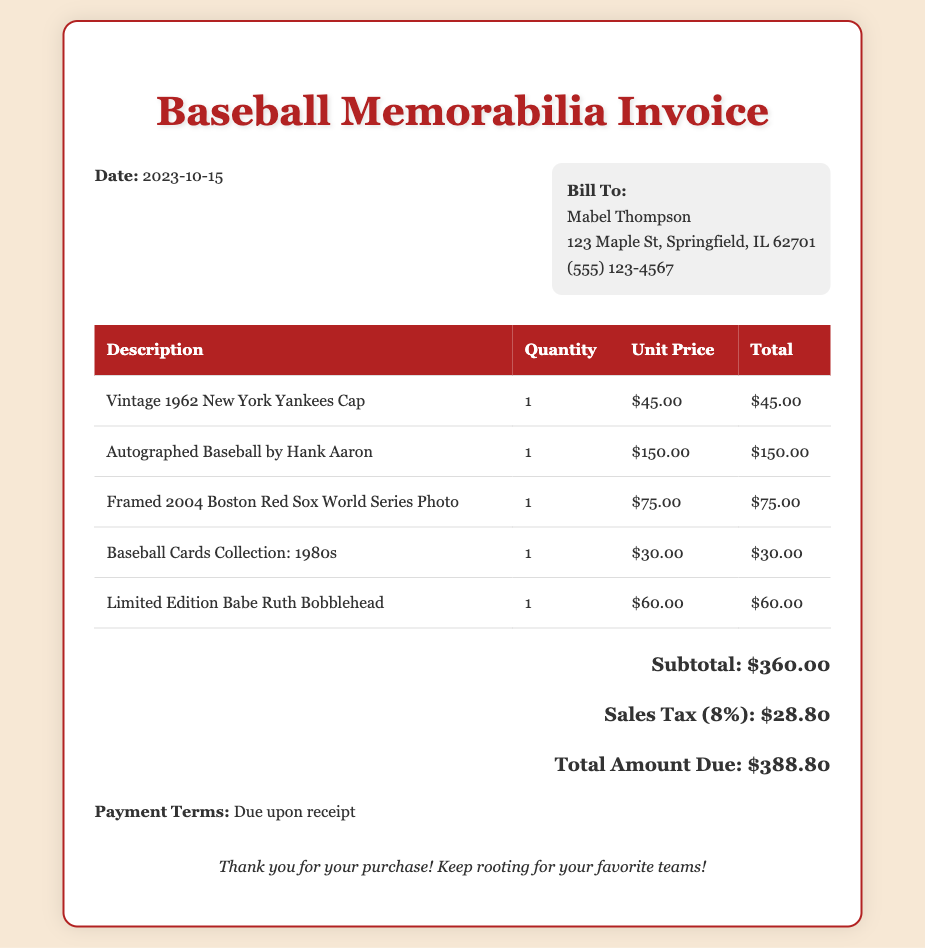What is the date of the invoice? The date of the invoice is stated at the top of the document.
Answer: 2023-10-15 Who is the invoice billed to? The "Bill To" section provides the name of the recipient of the invoice.
Answer: Mabel Thompson What is the total amount due? The total amount due is found in the summary of payment information.
Answer: $388.80 How many items are listed in the invoice? The number of items is determined by counting the rows in the itemized list.
Answer: 5 What is the unit price of the autographed baseball? The unit price is listed in the table corresponding to the autographed baseball item.
Answer: $150.00 What is the subtotal before tax? The subtotal is provided in the summary section of the invoice.
Answer: $360.00 What percentage is the sales tax? The amount of sales tax is expressed as a percentage in the document.
Answer: 8% What item has the highest price? By comparing the prices of all items listed, we identify the item with the highest cost.
Answer: Autographed Baseball by Hank Aaron What are the payment terms stated in the document? The payment terms are noted at the bottom of the invoice document.
Answer: Due upon receipt 